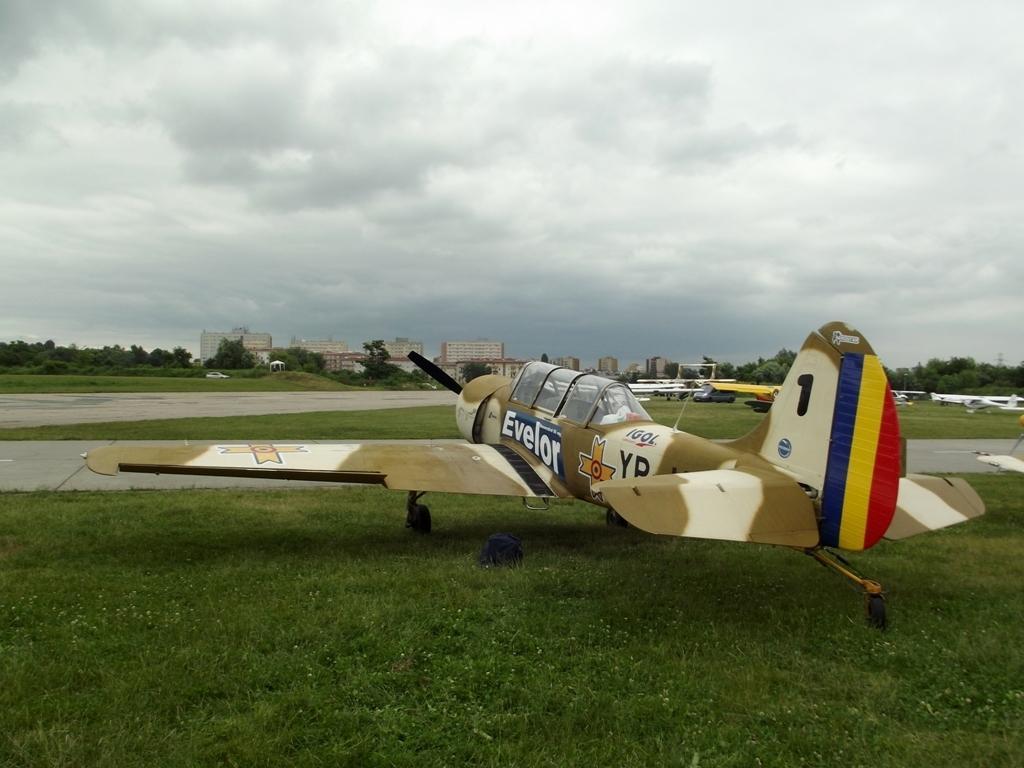In one or two sentences, can you explain what this image depicts? At the top of the image we can see sky with clouds, buildings, trees and road. At the bottom of the image we can see an aeroplane placed on the ground. 